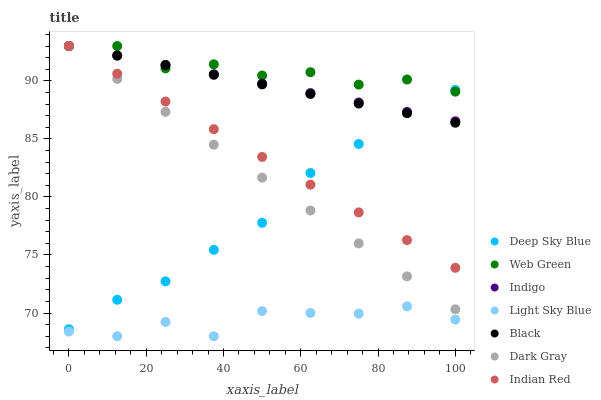Does Light Sky Blue have the minimum area under the curve?
Answer yes or no. Yes. Does Web Green have the maximum area under the curve?
Answer yes or no. Yes. Does Indian Red have the minimum area under the curve?
Answer yes or no. No. Does Indian Red have the maximum area under the curve?
Answer yes or no. No. Is Indian Red the smoothest?
Answer yes or no. Yes. Is Light Sky Blue the roughest?
Answer yes or no. Yes. Is Web Green the smoothest?
Answer yes or no. No. Is Web Green the roughest?
Answer yes or no. No. Does Light Sky Blue have the lowest value?
Answer yes or no. Yes. Does Indian Red have the lowest value?
Answer yes or no. No. Does Black have the highest value?
Answer yes or no. Yes. Does Light Sky Blue have the highest value?
Answer yes or no. No. Is Light Sky Blue less than Black?
Answer yes or no. Yes. Is Deep Sky Blue greater than Light Sky Blue?
Answer yes or no. Yes. Does Indian Red intersect Dark Gray?
Answer yes or no. Yes. Is Indian Red less than Dark Gray?
Answer yes or no. No. Is Indian Red greater than Dark Gray?
Answer yes or no. No. Does Light Sky Blue intersect Black?
Answer yes or no. No. 